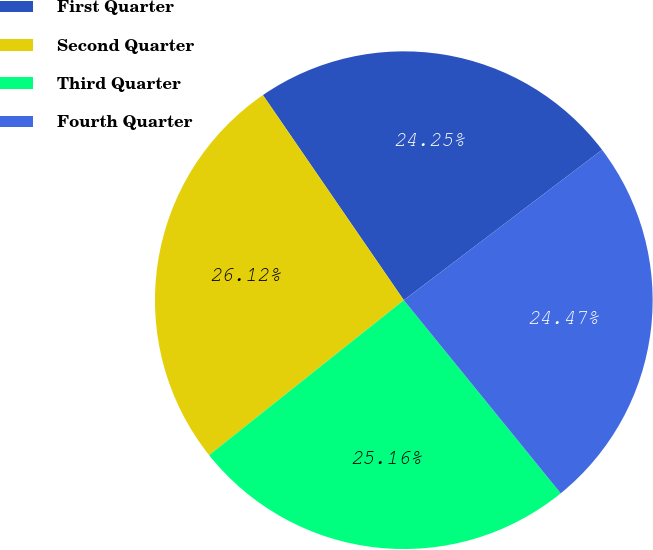<chart> <loc_0><loc_0><loc_500><loc_500><pie_chart><fcel>First Quarter<fcel>Second Quarter<fcel>Third Quarter<fcel>Fourth Quarter<nl><fcel>24.25%<fcel>26.12%<fcel>25.16%<fcel>24.47%<nl></chart> 